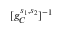<formula> <loc_0><loc_0><loc_500><loc_500>[ g _ { C } ^ { s _ { 1 } , s _ { 2 } } ] ^ { - 1 }</formula> 